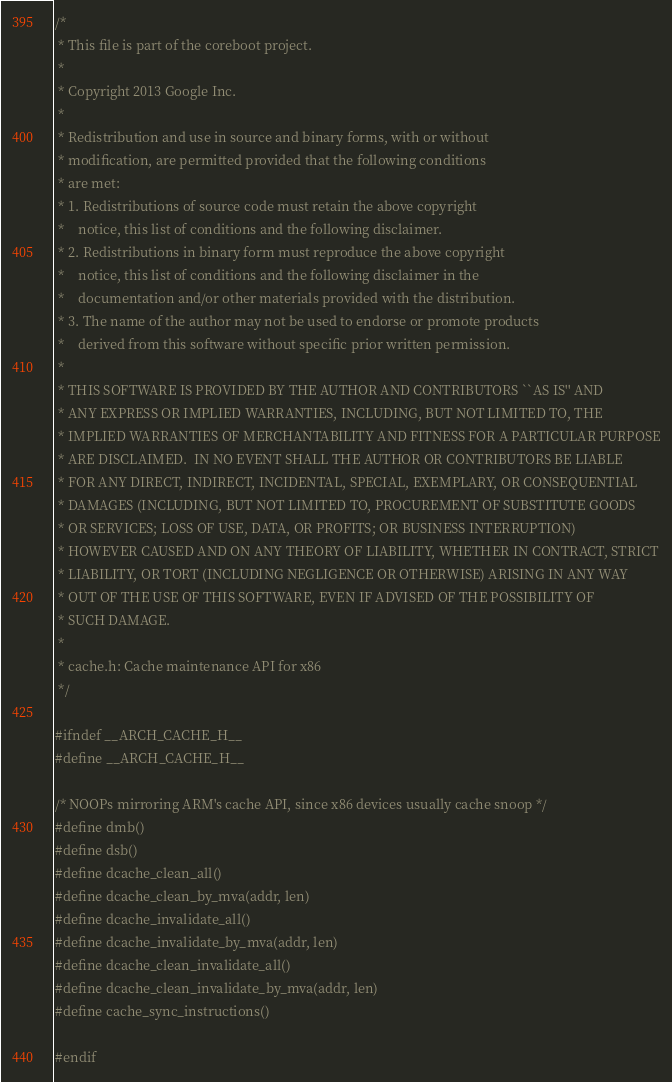<code> <loc_0><loc_0><loc_500><loc_500><_C_>/*
 * This file is part of the coreboot project.
 *
 * Copyright 2013 Google Inc.
 *
 * Redistribution and use in source and binary forms, with or without
 * modification, are permitted provided that the following conditions
 * are met:
 * 1. Redistributions of source code must retain the above copyright
 *    notice, this list of conditions and the following disclaimer.
 * 2. Redistributions in binary form must reproduce the above copyright
 *    notice, this list of conditions and the following disclaimer in the
 *    documentation and/or other materials provided with the distribution.
 * 3. The name of the author may not be used to endorse or promote products
 *    derived from this software without specific prior written permission.
 *
 * THIS SOFTWARE IS PROVIDED BY THE AUTHOR AND CONTRIBUTORS ``AS IS'' AND
 * ANY EXPRESS OR IMPLIED WARRANTIES, INCLUDING, BUT NOT LIMITED TO, THE
 * IMPLIED WARRANTIES OF MERCHANTABILITY AND FITNESS FOR A PARTICULAR PURPOSE
 * ARE DISCLAIMED.  IN NO EVENT SHALL THE AUTHOR OR CONTRIBUTORS BE LIABLE
 * FOR ANY DIRECT, INDIRECT, INCIDENTAL, SPECIAL, EXEMPLARY, OR CONSEQUENTIAL
 * DAMAGES (INCLUDING, BUT NOT LIMITED TO, PROCUREMENT OF SUBSTITUTE GOODS
 * OR SERVICES; LOSS OF USE, DATA, OR PROFITS; OR BUSINESS INTERRUPTION)
 * HOWEVER CAUSED AND ON ANY THEORY OF LIABILITY, WHETHER IN CONTRACT, STRICT
 * LIABILITY, OR TORT (INCLUDING NEGLIGENCE OR OTHERWISE) ARISING IN ANY WAY
 * OUT OF THE USE OF THIS SOFTWARE, EVEN IF ADVISED OF THE POSSIBILITY OF
 * SUCH DAMAGE.
 *
 * cache.h: Cache maintenance API for x86
 */

#ifndef __ARCH_CACHE_H__
#define __ARCH_CACHE_H__

/* NOOPs mirroring ARM's cache API, since x86 devices usually cache snoop */
#define dmb()
#define dsb()
#define dcache_clean_all()
#define dcache_clean_by_mva(addr, len)
#define dcache_invalidate_all()
#define dcache_invalidate_by_mva(addr, len)
#define dcache_clean_invalidate_all()
#define dcache_clean_invalidate_by_mva(addr, len)
#define cache_sync_instructions()

#endif
</code> 